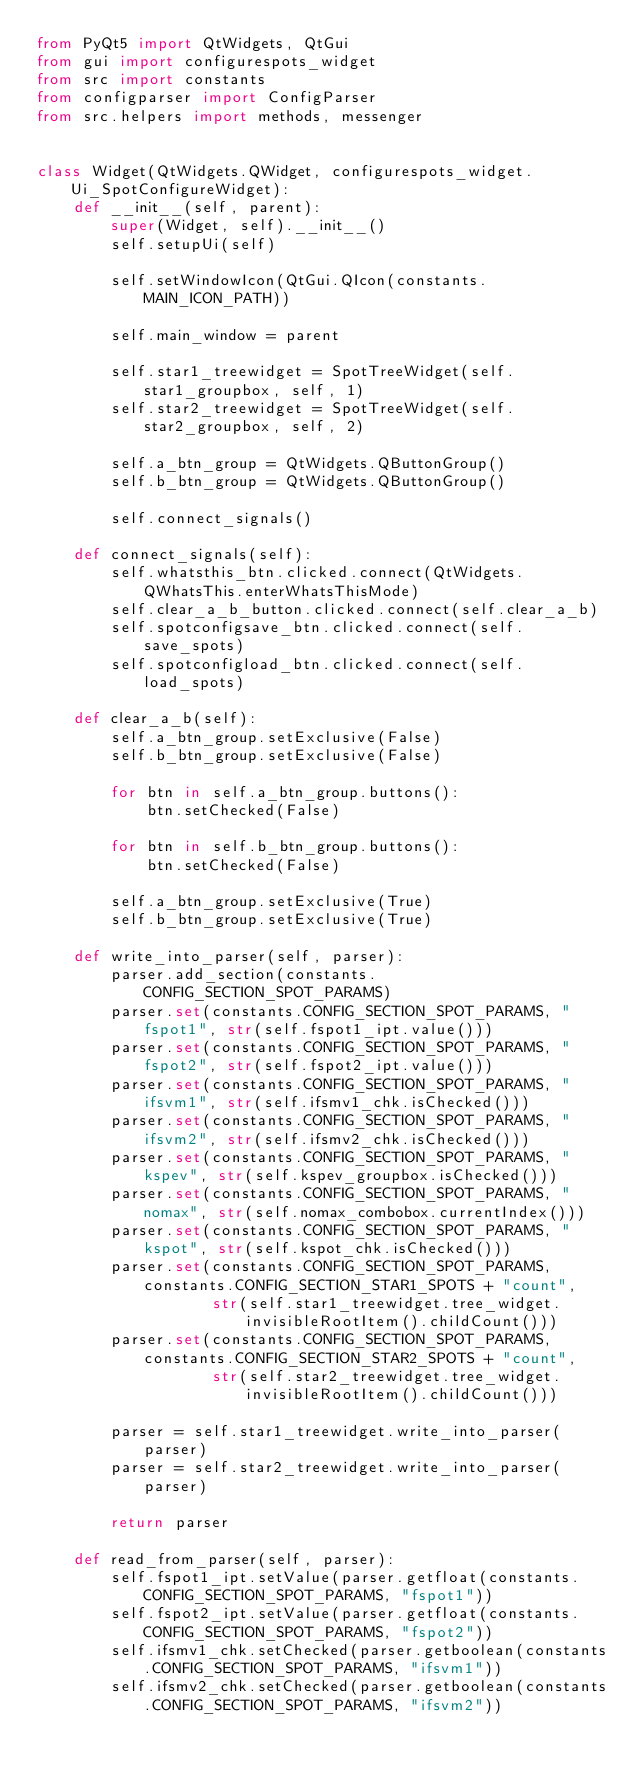Convert code to text. <code><loc_0><loc_0><loc_500><loc_500><_Python_>from PyQt5 import QtWidgets, QtGui
from gui import configurespots_widget
from src import constants
from configparser import ConfigParser
from src.helpers import methods, messenger


class Widget(QtWidgets.QWidget, configurespots_widget.Ui_SpotConfigureWidget):
    def __init__(self, parent):
        super(Widget, self).__init__()
        self.setupUi(self)

        self.setWindowIcon(QtGui.QIcon(constants.MAIN_ICON_PATH))

        self.main_window = parent

        self.star1_treewidget = SpotTreeWidget(self.star1_groupbox, self, 1)
        self.star2_treewidget = SpotTreeWidget(self.star2_groupbox, self, 2)

        self.a_btn_group = QtWidgets.QButtonGroup()
        self.b_btn_group = QtWidgets.QButtonGroup()

        self.connect_signals()

    def connect_signals(self):
        self.whatsthis_btn.clicked.connect(QtWidgets.QWhatsThis.enterWhatsThisMode)
        self.clear_a_b_button.clicked.connect(self.clear_a_b)
        self.spotconfigsave_btn.clicked.connect(self.save_spots)
        self.spotconfigload_btn.clicked.connect(self.load_spots)

    def clear_a_b(self):
        self.a_btn_group.setExclusive(False)
        self.b_btn_group.setExclusive(False)

        for btn in self.a_btn_group.buttons():
            btn.setChecked(False)

        for btn in self.b_btn_group.buttons():
            btn.setChecked(False)

        self.a_btn_group.setExclusive(True)
        self.b_btn_group.setExclusive(True)

    def write_into_parser(self, parser):
        parser.add_section(constants.CONFIG_SECTION_SPOT_PARAMS)
        parser.set(constants.CONFIG_SECTION_SPOT_PARAMS, "fspot1", str(self.fspot1_ipt.value()))
        parser.set(constants.CONFIG_SECTION_SPOT_PARAMS, "fspot2", str(self.fspot2_ipt.value()))
        parser.set(constants.CONFIG_SECTION_SPOT_PARAMS, "ifsvm1", str(self.ifsmv1_chk.isChecked()))
        parser.set(constants.CONFIG_SECTION_SPOT_PARAMS, "ifsvm2", str(self.ifsmv2_chk.isChecked()))
        parser.set(constants.CONFIG_SECTION_SPOT_PARAMS, "kspev", str(self.kspev_groupbox.isChecked()))
        parser.set(constants.CONFIG_SECTION_SPOT_PARAMS, "nomax", str(self.nomax_combobox.currentIndex()))
        parser.set(constants.CONFIG_SECTION_SPOT_PARAMS, "kspot", str(self.kspot_chk.isChecked()))
        parser.set(constants.CONFIG_SECTION_SPOT_PARAMS, constants.CONFIG_SECTION_STAR1_SPOTS + "count",
                   str(self.star1_treewidget.tree_widget.invisibleRootItem().childCount()))
        parser.set(constants.CONFIG_SECTION_SPOT_PARAMS, constants.CONFIG_SECTION_STAR2_SPOTS + "count",
                   str(self.star2_treewidget.tree_widget.invisibleRootItem().childCount()))

        parser = self.star1_treewidget.write_into_parser(parser)
        parser = self.star2_treewidget.write_into_parser(parser)

        return parser

    def read_from_parser(self, parser):
        self.fspot1_ipt.setValue(parser.getfloat(constants.CONFIG_SECTION_SPOT_PARAMS, "fspot1"))
        self.fspot2_ipt.setValue(parser.getfloat(constants.CONFIG_SECTION_SPOT_PARAMS, "fspot2"))
        self.ifsmv1_chk.setChecked(parser.getboolean(constants.CONFIG_SECTION_SPOT_PARAMS, "ifsvm1"))
        self.ifsmv2_chk.setChecked(parser.getboolean(constants.CONFIG_SECTION_SPOT_PARAMS, "ifsvm2"))</code> 